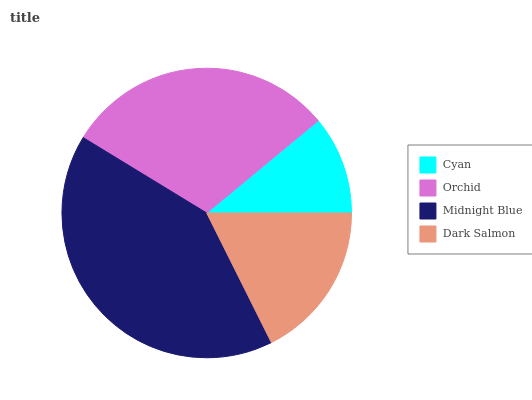Is Cyan the minimum?
Answer yes or no. Yes. Is Midnight Blue the maximum?
Answer yes or no. Yes. Is Orchid the minimum?
Answer yes or no. No. Is Orchid the maximum?
Answer yes or no. No. Is Orchid greater than Cyan?
Answer yes or no. Yes. Is Cyan less than Orchid?
Answer yes or no. Yes. Is Cyan greater than Orchid?
Answer yes or no. No. Is Orchid less than Cyan?
Answer yes or no. No. Is Orchid the high median?
Answer yes or no. Yes. Is Dark Salmon the low median?
Answer yes or no. Yes. Is Cyan the high median?
Answer yes or no. No. Is Orchid the low median?
Answer yes or no. No. 